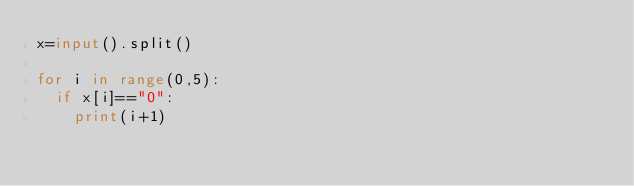<code> <loc_0><loc_0><loc_500><loc_500><_Python_>x=input().split()

for i in range(0,5):
  if x[i]=="0":
    print(i+1)</code> 